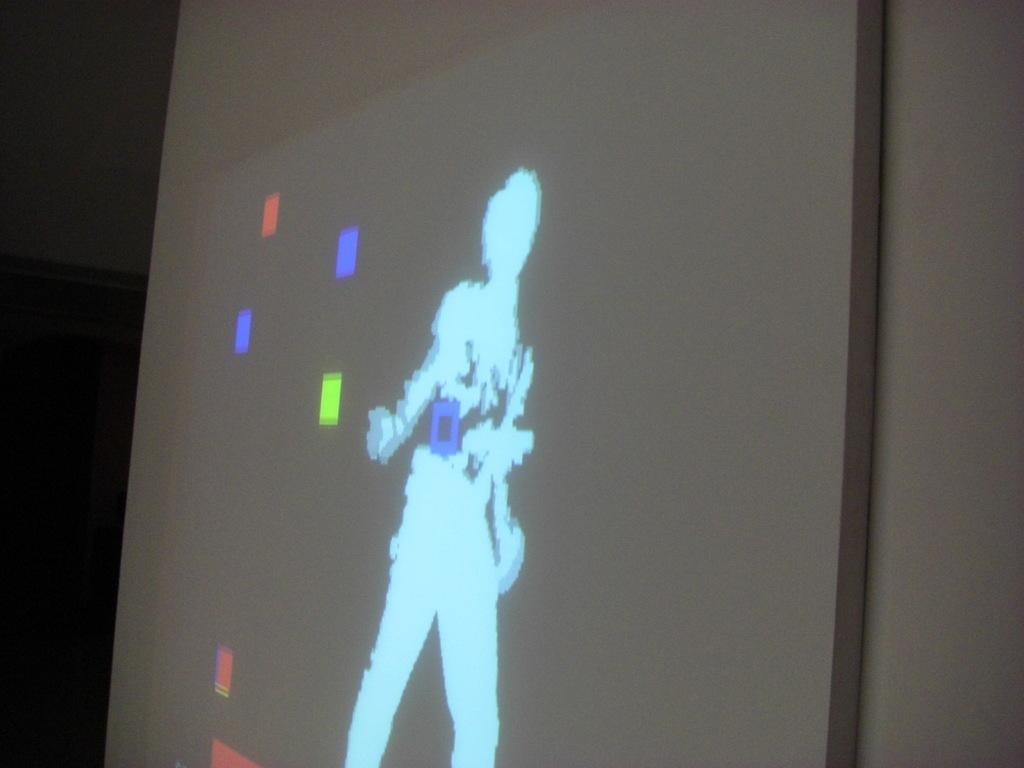How would you summarize this image in a sentence or two? In the picture we can see a part of the screen with some colors on it and we can see a person's image. 